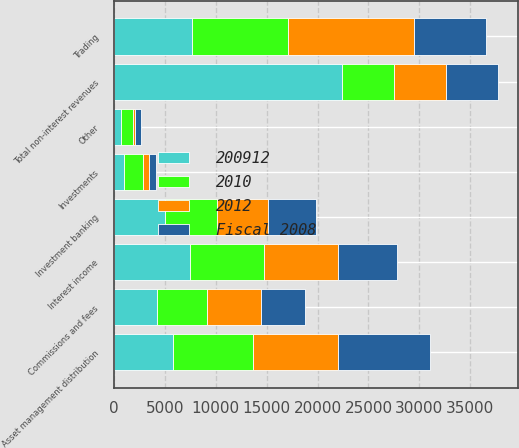Convert chart to OTSL. <chart><loc_0><loc_0><loc_500><loc_500><stacked_bar_chart><ecel><fcel>Investment banking<fcel>Trading<fcel>Investments<fcel>Commissions and fees<fcel>Asset management distribution<fcel>Other<fcel>Total non-interest revenues<fcel>Interest income<nl><fcel>Fiscal 2008<fcel>4758<fcel>6991<fcel>742<fcel>4257<fcel>9008<fcel>555<fcel>5122<fcel>5725<nl><fcel>2012<fcel>4991<fcel>12384<fcel>573<fcel>5347<fcel>8410<fcel>175<fcel>5122<fcel>7258<nl><fcel>2010<fcel>5122<fcel>9393<fcel>1825<fcel>4913<fcel>7843<fcel>1236<fcel>5122<fcel>7305<nl><fcel>200912<fcel>5020<fcel>7722<fcel>1034<fcel>4212<fcel>5802<fcel>671<fcel>22393<fcel>7472<nl></chart> 